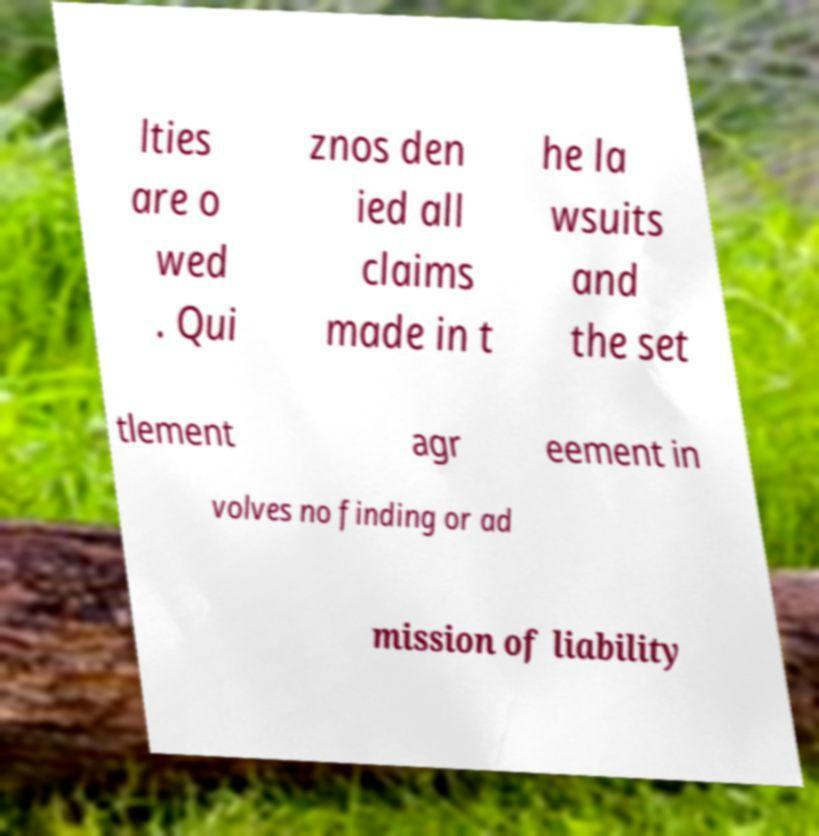Please identify and transcribe the text found in this image. lties are o wed . Qui znos den ied all claims made in t he la wsuits and the set tlement agr eement in volves no finding or ad mission of liability 